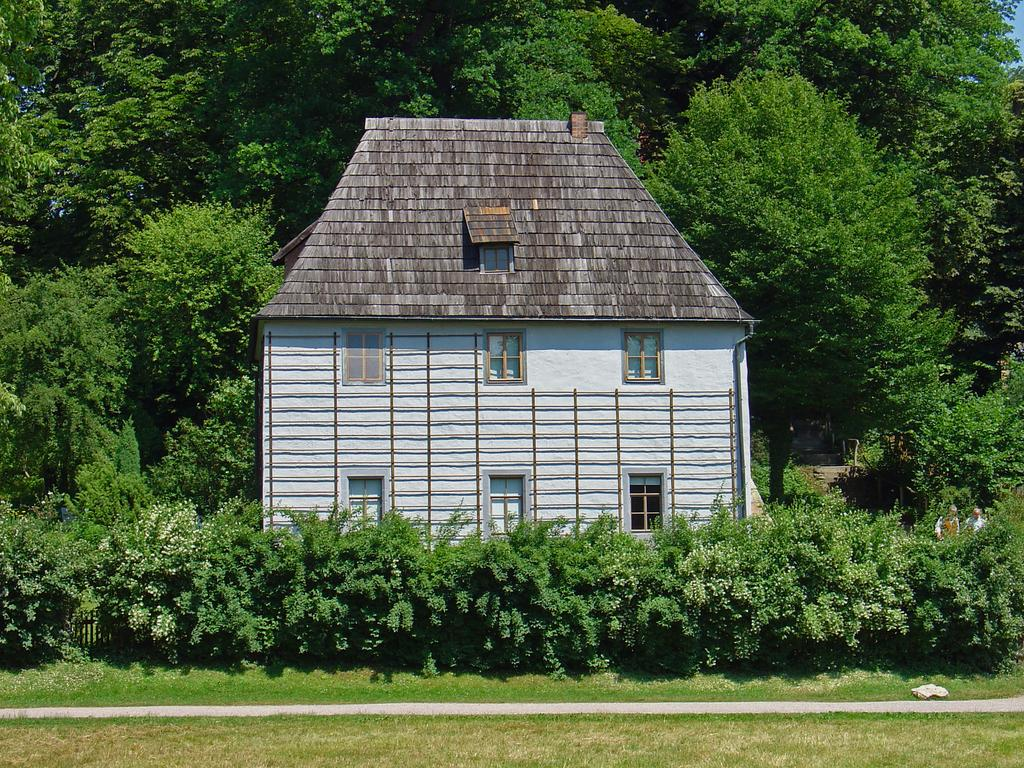What type of vegetation is present at the bottom of the image? There are many grasses at the bottom of the image. What structure is located in the middle of the image? There is a house in the middle of the image. How is the house decorated or surrounded? The house is covered with trees and plants. What can be seen in the background of the image? The background of the image is the sky. How many children are wearing stockings in the image? There are no children or stockings present in the image. What color is the nose of the person in the image? There is no person or nose present in the image. 